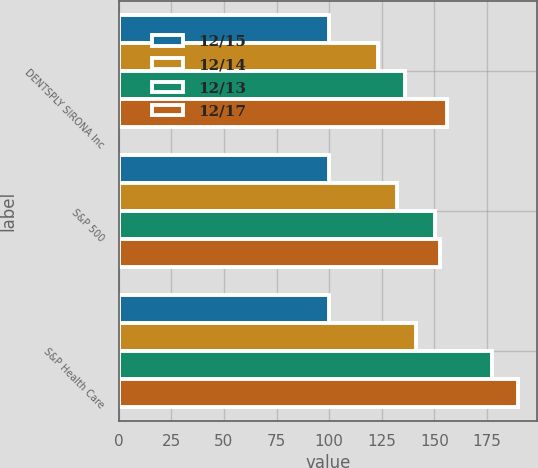<chart> <loc_0><loc_0><loc_500><loc_500><stacked_bar_chart><ecel><fcel>DENTSPLY SIRONA Inc<fcel>S&P 500<fcel>S&P Health Care<nl><fcel>12/15<fcel>100<fcel>100<fcel>100<nl><fcel>12/14<fcel>123.1<fcel>132.39<fcel>141.46<nl><fcel>12/13<fcel>136.01<fcel>150.51<fcel>177.3<nl><fcel>12/17<fcel>156.2<fcel>152.59<fcel>189.52<nl></chart> 